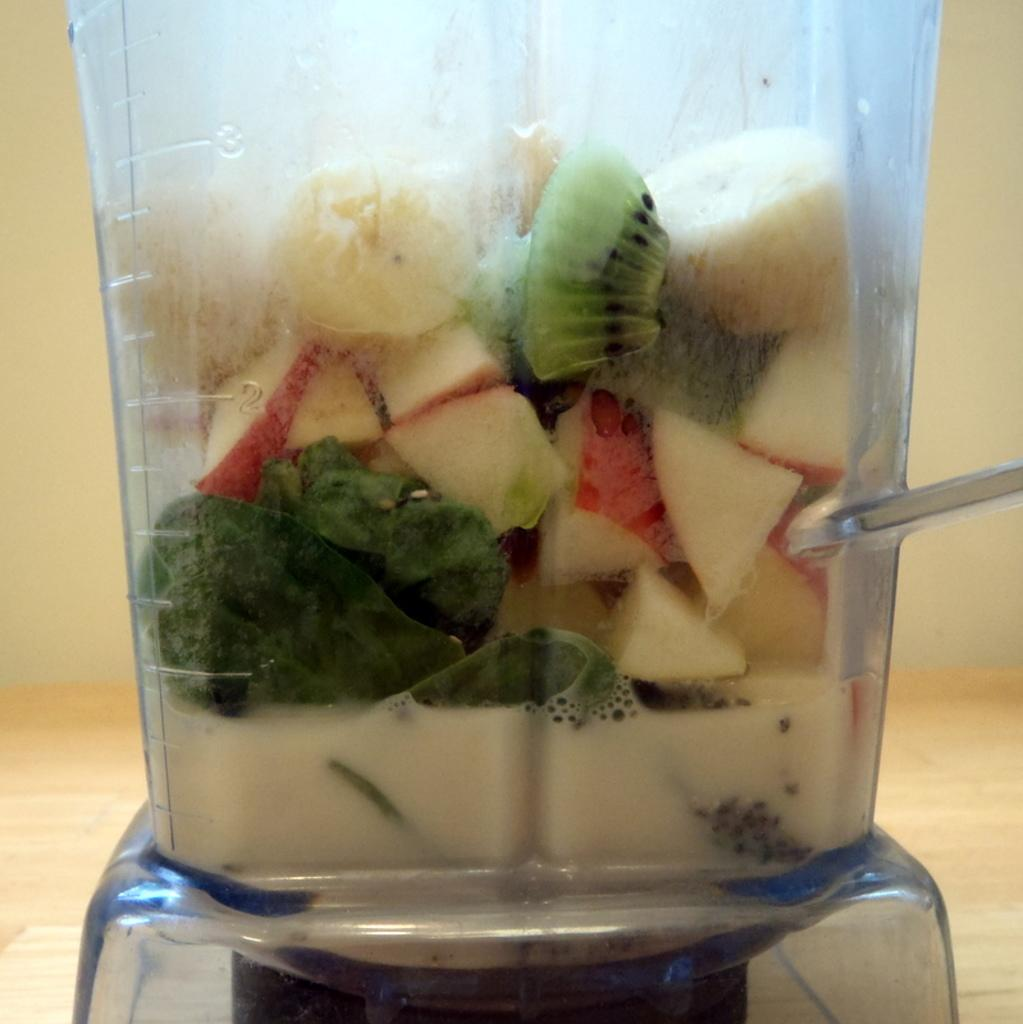What type of food can be seen in the image? There are fruit pieces in the image. Where are the fruit pieces located? The fruit pieces are in a jar. What type of record can be seen in the image? There is no record present in the image; it features fruit pieces in a jar. What type of sock is visible on the fruit pieces in the image? There is no sock present in the image, as it features fruit pieces in a jar. 